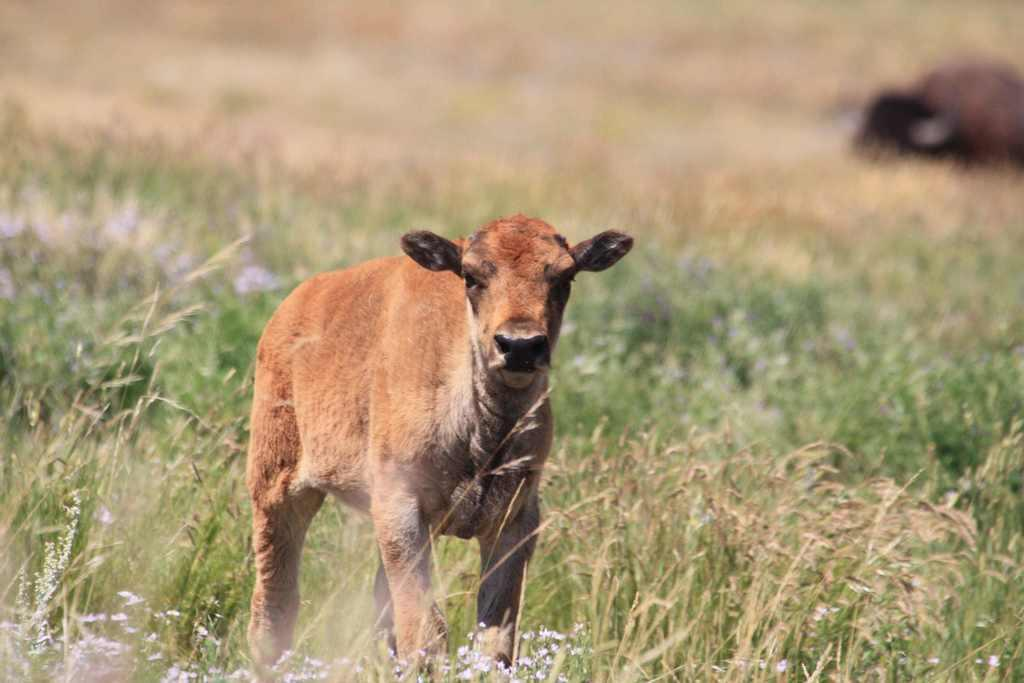What is the main setting of the image? There is an open grass ground in the image. What animal can be seen in the image? A brown-colored calf is standing in the front of the image. How would you describe the quality of the image? The image is slightly blurry in the background. How many jewels can be seen around the calf's neck in the image? There are no jewels present around the calf's neck in the image. How many babies are visible in the image? There are no babies visible in the image; it features an open grass ground and a brown-colored calf. 